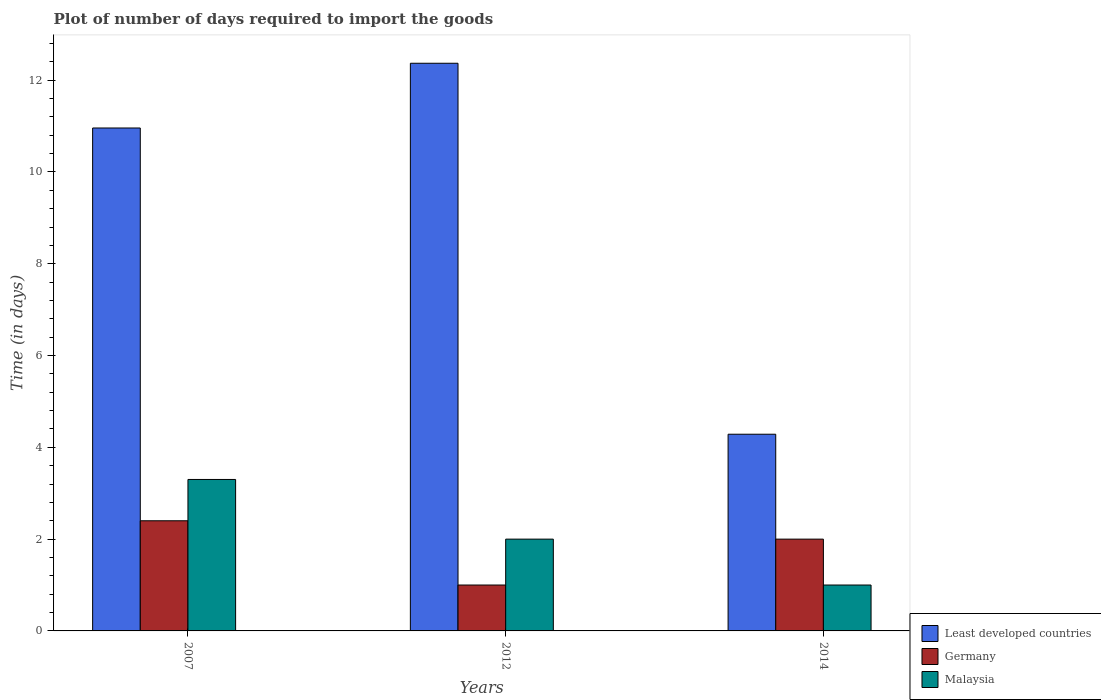How many different coloured bars are there?
Offer a terse response. 3. How many groups of bars are there?
Provide a short and direct response. 3. What is the label of the 3rd group of bars from the left?
Provide a succinct answer. 2014. Across all years, what is the maximum time required to import goods in Germany?
Make the answer very short. 2.4. Across all years, what is the minimum time required to import goods in Malaysia?
Give a very brief answer. 1. In which year was the time required to import goods in Malaysia maximum?
Offer a terse response. 2007. What is the average time required to import goods in Least developed countries per year?
Provide a succinct answer. 9.2. In the year 2012, what is the difference between the time required to import goods in Least developed countries and time required to import goods in Malaysia?
Provide a short and direct response. 10.37. What is the ratio of the time required to import goods in Least developed countries in 2007 to that in 2012?
Make the answer very short. 0.89. Is the difference between the time required to import goods in Least developed countries in 2007 and 2012 greater than the difference between the time required to import goods in Malaysia in 2007 and 2012?
Your answer should be compact. No. What is the difference between the highest and the second highest time required to import goods in Malaysia?
Provide a succinct answer. 1.3. In how many years, is the time required to import goods in Germany greater than the average time required to import goods in Germany taken over all years?
Your response must be concise. 2. Is the sum of the time required to import goods in Germany in 2007 and 2012 greater than the maximum time required to import goods in Least developed countries across all years?
Ensure brevity in your answer.  No. What does the 3rd bar from the left in 2007 represents?
Ensure brevity in your answer.  Malaysia. What does the 1st bar from the right in 2012 represents?
Make the answer very short. Malaysia. Is it the case that in every year, the sum of the time required to import goods in Least developed countries and time required to import goods in Malaysia is greater than the time required to import goods in Germany?
Provide a short and direct response. Yes. Are all the bars in the graph horizontal?
Your answer should be very brief. No. How many years are there in the graph?
Give a very brief answer. 3. What is the title of the graph?
Make the answer very short. Plot of number of days required to import the goods. What is the label or title of the Y-axis?
Offer a terse response. Time (in days). What is the Time (in days) in Least developed countries in 2007?
Your answer should be very brief. 10.96. What is the Time (in days) in Germany in 2007?
Offer a very short reply. 2.4. What is the Time (in days) of Least developed countries in 2012?
Offer a very short reply. 12.37. What is the Time (in days) of Germany in 2012?
Your answer should be very brief. 1. What is the Time (in days) in Malaysia in 2012?
Make the answer very short. 2. What is the Time (in days) in Least developed countries in 2014?
Provide a succinct answer. 4.29. What is the Time (in days) in Germany in 2014?
Your answer should be compact. 2. What is the Time (in days) in Malaysia in 2014?
Make the answer very short. 1. Across all years, what is the maximum Time (in days) of Least developed countries?
Ensure brevity in your answer.  12.37. Across all years, what is the maximum Time (in days) of Germany?
Keep it short and to the point. 2.4. Across all years, what is the minimum Time (in days) in Least developed countries?
Keep it short and to the point. 4.29. Across all years, what is the minimum Time (in days) of Malaysia?
Make the answer very short. 1. What is the total Time (in days) of Least developed countries in the graph?
Offer a very short reply. 27.61. What is the total Time (in days) in Malaysia in the graph?
Ensure brevity in your answer.  6.3. What is the difference between the Time (in days) of Least developed countries in 2007 and that in 2012?
Your answer should be compact. -1.41. What is the difference between the Time (in days) in Germany in 2007 and that in 2012?
Your answer should be compact. 1.4. What is the difference between the Time (in days) in Malaysia in 2007 and that in 2012?
Provide a short and direct response. 1.3. What is the difference between the Time (in days) of Least developed countries in 2007 and that in 2014?
Give a very brief answer. 6.67. What is the difference between the Time (in days) in Germany in 2007 and that in 2014?
Keep it short and to the point. 0.4. What is the difference between the Time (in days) of Least developed countries in 2012 and that in 2014?
Ensure brevity in your answer.  8.08. What is the difference between the Time (in days) of Germany in 2012 and that in 2014?
Your response must be concise. -1. What is the difference between the Time (in days) of Least developed countries in 2007 and the Time (in days) of Germany in 2012?
Make the answer very short. 9.96. What is the difference between the Time (in days) in Least developed countries in 2007 and the Time (in days) in Malaysia in 2012?
Offer a very short reply. 8.96. What is the difference between the Time (in days) in Least developed countries in 2007 and the Time (in days) in Germany in 2014?
Give a very brief answer. 8.96. What is the difference between the Time (in days) in Least developed countries in 2007 and the Time (in days) in Malaysia in 2014?
Your answer should be very brief. 9.96. What is the difference between the Time (in days) of Germany in 2007 and the Time (in days) of Malaysia in 2014?
Provide a succinct answer. 1.4. What is the difference between the Time (in days) of Least developed countries in 2012 and the Time (in days) of Germany in 2014?
Your answer should be very brief. 10.37. What is the difference between the Time (in days) in Least developed countries in 2012 and the Time (in days) in Malaysia in 2014?
Provide a short and direct response. 11.37. What is the difference between the Time (in days) in Germany in 2012 and the Time (in days) in Malaysia in 2014?
Your answer should be very brief. 0. What is the average Time (in days) in Least developed countries per year?
Your answer should be compact. 9.2. What is the average Time (in days) of Germany per year?
Your answer should be very brief. 1.8. What is the average Time (in days) of Malaysia per year?
Offer a terse response. 2.1. In the year 2007, what is the difference between the Time (in days) of Least developed countries and Time (in days) of Germany?
Give a very brief answer. 8.56. In the year 2007, what is the difference between the Time (in days) of Least developed countries and Time (in days) of Malaysia?
Keep it short and to the point. 7.66. In the year 2007, what is the difference between the Time (in days) in Germany and Time (in days) in Malaysia?
Provide a succinct answer. -0.9. In the year 2012, what is the difference between the Time (in days) in Least developed countries and Time (in days) in Germany?
Make the answer very short. 11.37. In the year 2012, what is the difference between the Time (in days) in Least developed countries and Time (in days) in Malaysia?
Make the answer very short. 10.37. In the year 2012, what is the difference between the Time (in days) in Germany and Time (in days) in Malaysia?
Your response must be concise. -1. In the year 2014, what is the difference between the Time (in days) of Least developed countries and Time (in days) of Germany?
Offer a very short reply. 2.29. In the year 2014, what is the difference between the Time (in days) of Least developed countries and Time (in days) of Malaysia?
Keep it short and to the point. 3.29. In the year 2014, what is the difference between the Time (in days) of Germany and Time (in days) of Malaysia?
Offer a terse response. 1. What is the ratio of the Time (in days) in Least developed countries in 2007 to that in 2012?
Make the answer very short. 0.89. What is the ratio of the Time (in days) of Germany in 2007 to that in 2012?
Your answer should be compact. 2.4. What is the ratio of the Time (in days) of Malaysia in 2007 to that in 2012?
Your answer should be compact. 1.65. What is the ratio of the Time (in days) of Least developed countries in 2007 to that in 2014?
Provide a succinct answer. 2.56. What is the ratio of the Time (in days) in Germany in 2007 to that in 2014?
Ensure brevity in your answer.  1.2. What is the ratio of the Time (in days) in Malaysia in 2007 to that in 2014?
Give a very brief answer. 3.3. What is the ratio of the Time (in days) in Least developed countries in 2012 to that in 2014?
Ensure brevity in your answer.  2.89. What is the ratio of the Time (in days) of Germany in 2012 to that in 2014?
Offer a very short reply. 0.5. What is the ratio of the Time (in days) of Malaysia in 2012 to that in 2014?
Keep it short and to the point. 2. What is the difference between the highest and the second highest Time (in days) of Least developed countries?
Provide a succinct answer. 1.41. What is the difference between the highest and the lowest Time (in days) of Least developed countries?
Make the answer very short. 8.08. 